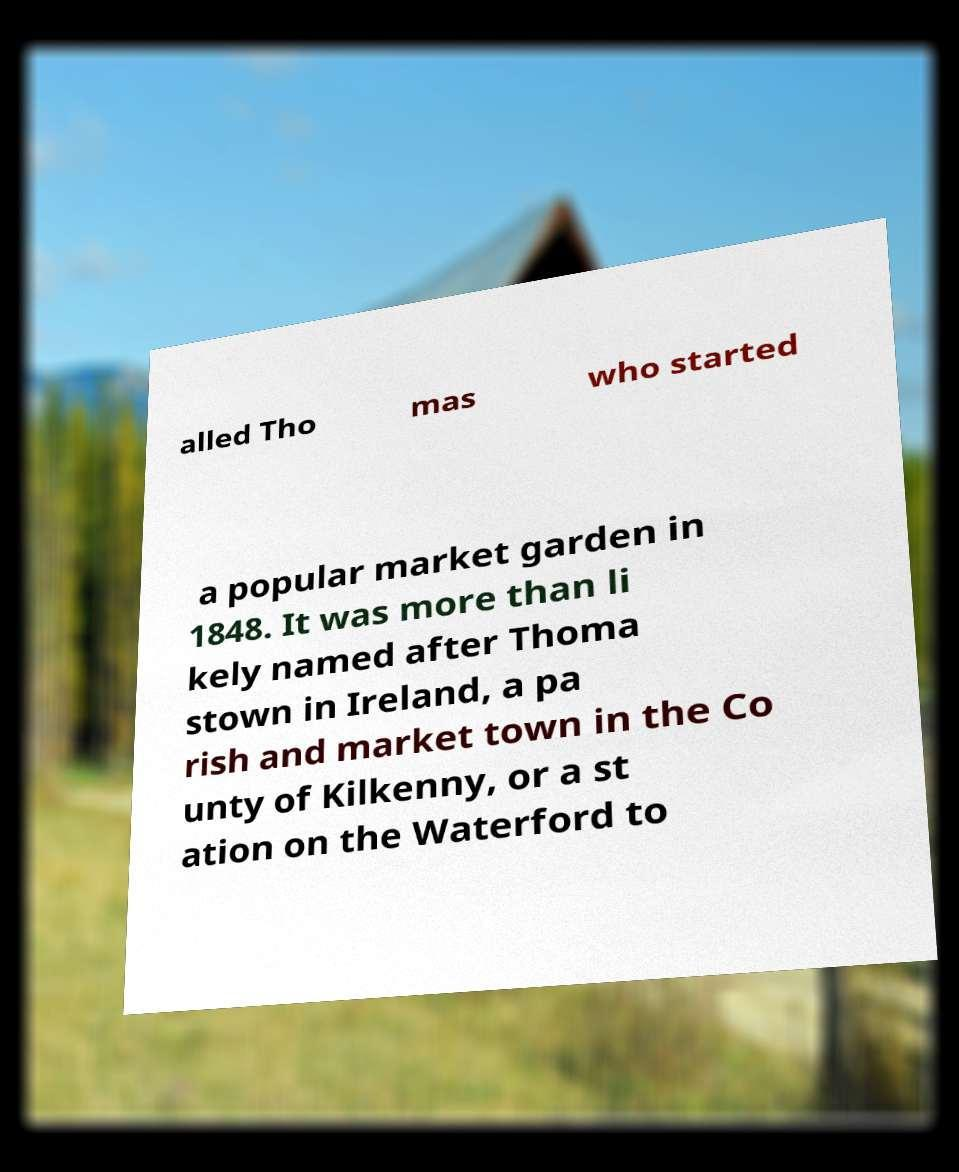Can you accurately transcribe the text from the provided image for me? alled Tho mas who started a popular market garden in 1848. It was more than li kely named after Thoma stown in Ireland, a pa rish and market town in the Co unty of Kilkenny, or a st ation on the Waterford to 